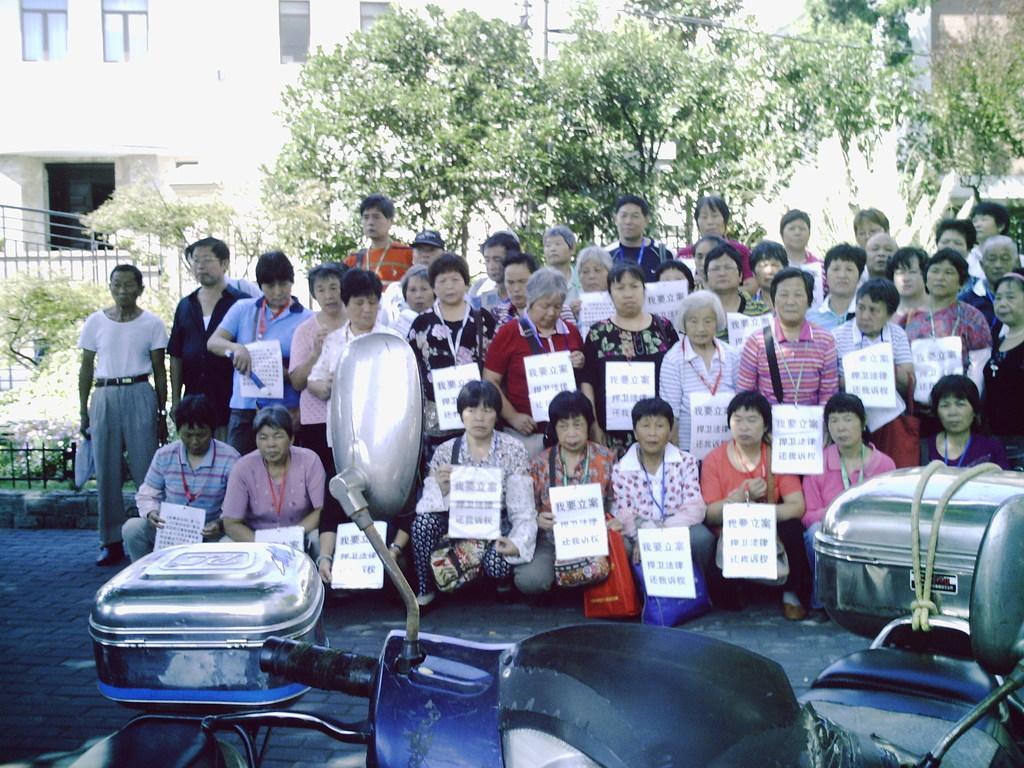In one or two sentences, can you explain what this image depicts? In this image we can see a group of people in which some are sitting and some are standing. There are many trees in the image. We can see a few buildings in the image. There are two motorbikes are parked at the bottom of the image. 